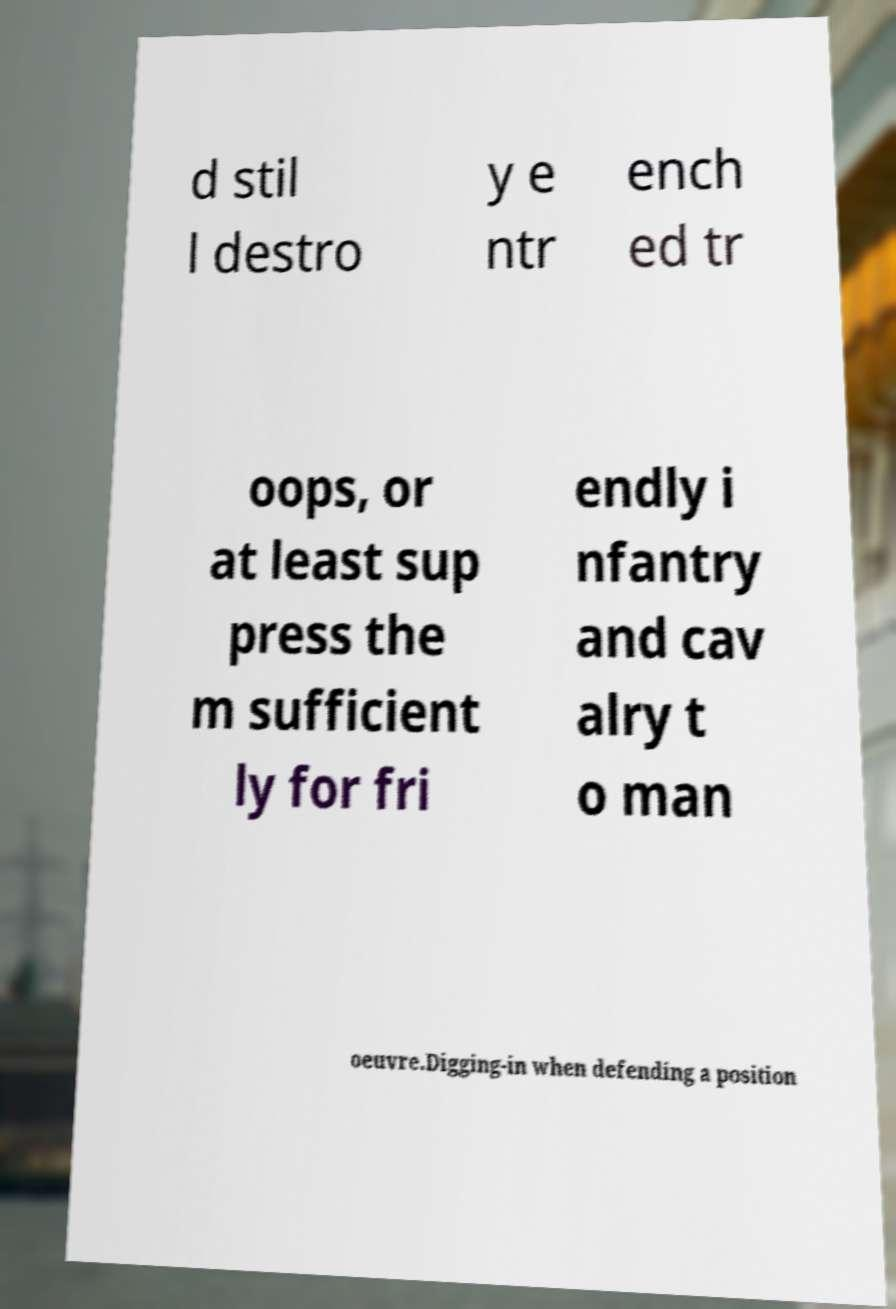Please identify and transcribe the text found in this image. d stil l destro y e ntr ench ed tr oops, or at least sup press the m sufficient ly for fri endly i nfantry and cav alry t o man oeuvre.Digging-in when defending a position 